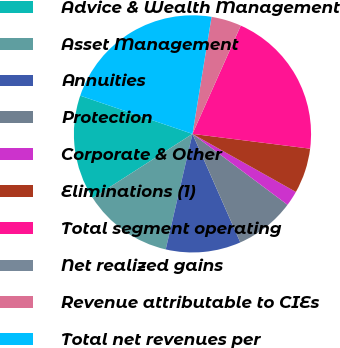Convert chart to OTSL. <chart><loc_0><loc_0><loc_500><loc_500><pie_chart><fcel>Advice & Wealth Management<fcel>Asset Management<fcel>Annuities<fcel>Protection<fcel>Corporate & Other<fcel>Eliminations (1)<fcel>Total segment operating<fcel>Net realized gains<fcel>Revenue attributable to CIEs<fcel>Total net revenues per<nl><fcel>14.32%<fcel>12.28%<fcel>10.23%<fcel>8.19%<fcel>2.06%<fcel>6.15%<fcel>20.31%<fcel>0.01%<fcel>4.1%<fcel>22.35%<nl></chart> 